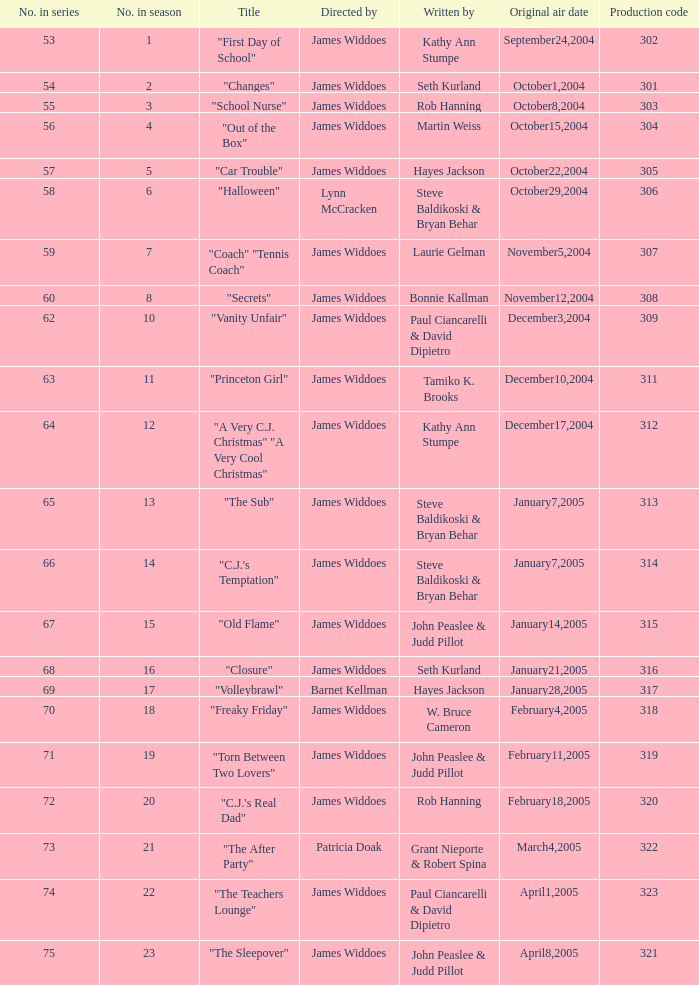How many manufacturing codes are there for "the sub"? 1.0. 